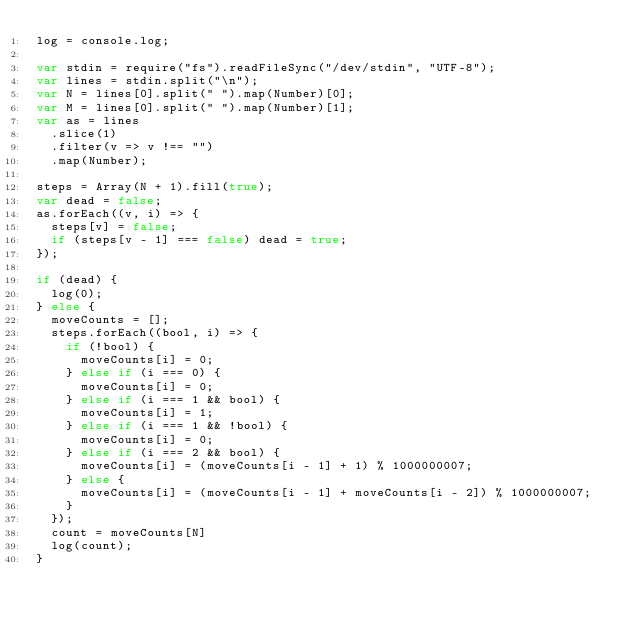<code> <loc_0><loc_0><loc_500><loc_500><_JavaScript_>log = console.log;

var stdin = require("fs").readFileSync("/dev/stdin", "UTF-8");
var lines = stdin.split("\n");
var N = lines[0].split(" ").map(Number)[0];
var M = lines[0].split(" ").map(Number)[1];
var as = lines
  .slice(1)
  .filter(v => v !== "")
  .map(Number);

steps = Array(N + 1).fill(true);
var dead = false;
as.forEach((v, i) => {
  steps[v] = false;
  if (steps[v - 1] === false) dead = true;
});

if (dead) {
  log(0);
} else {
  moveCounts = [];
  steps.forEach((bool, i) => {
    if (!bool) {
      moveCounts[i] = 0;
    } else if (i === 0) {
      moveCounts[i] = 0;
    } else if (i === 1 && bool) {
      moveCounts[i] = 1;
    } else if (i === 1 && !bool) {
      moveCounts[i] = 0;
    } else if (i === 2 && bool) {
      moveCounts[i] = (moveCounts[i - 1] + 1) % 1000000007;
    } else {
      moveCounts[i] = (moveCounts[i - 1] + moveCounts[i - 2]) % 1000000007;
    }
  });
  count = moveCounts[N]
  log(count);
}
</code> 